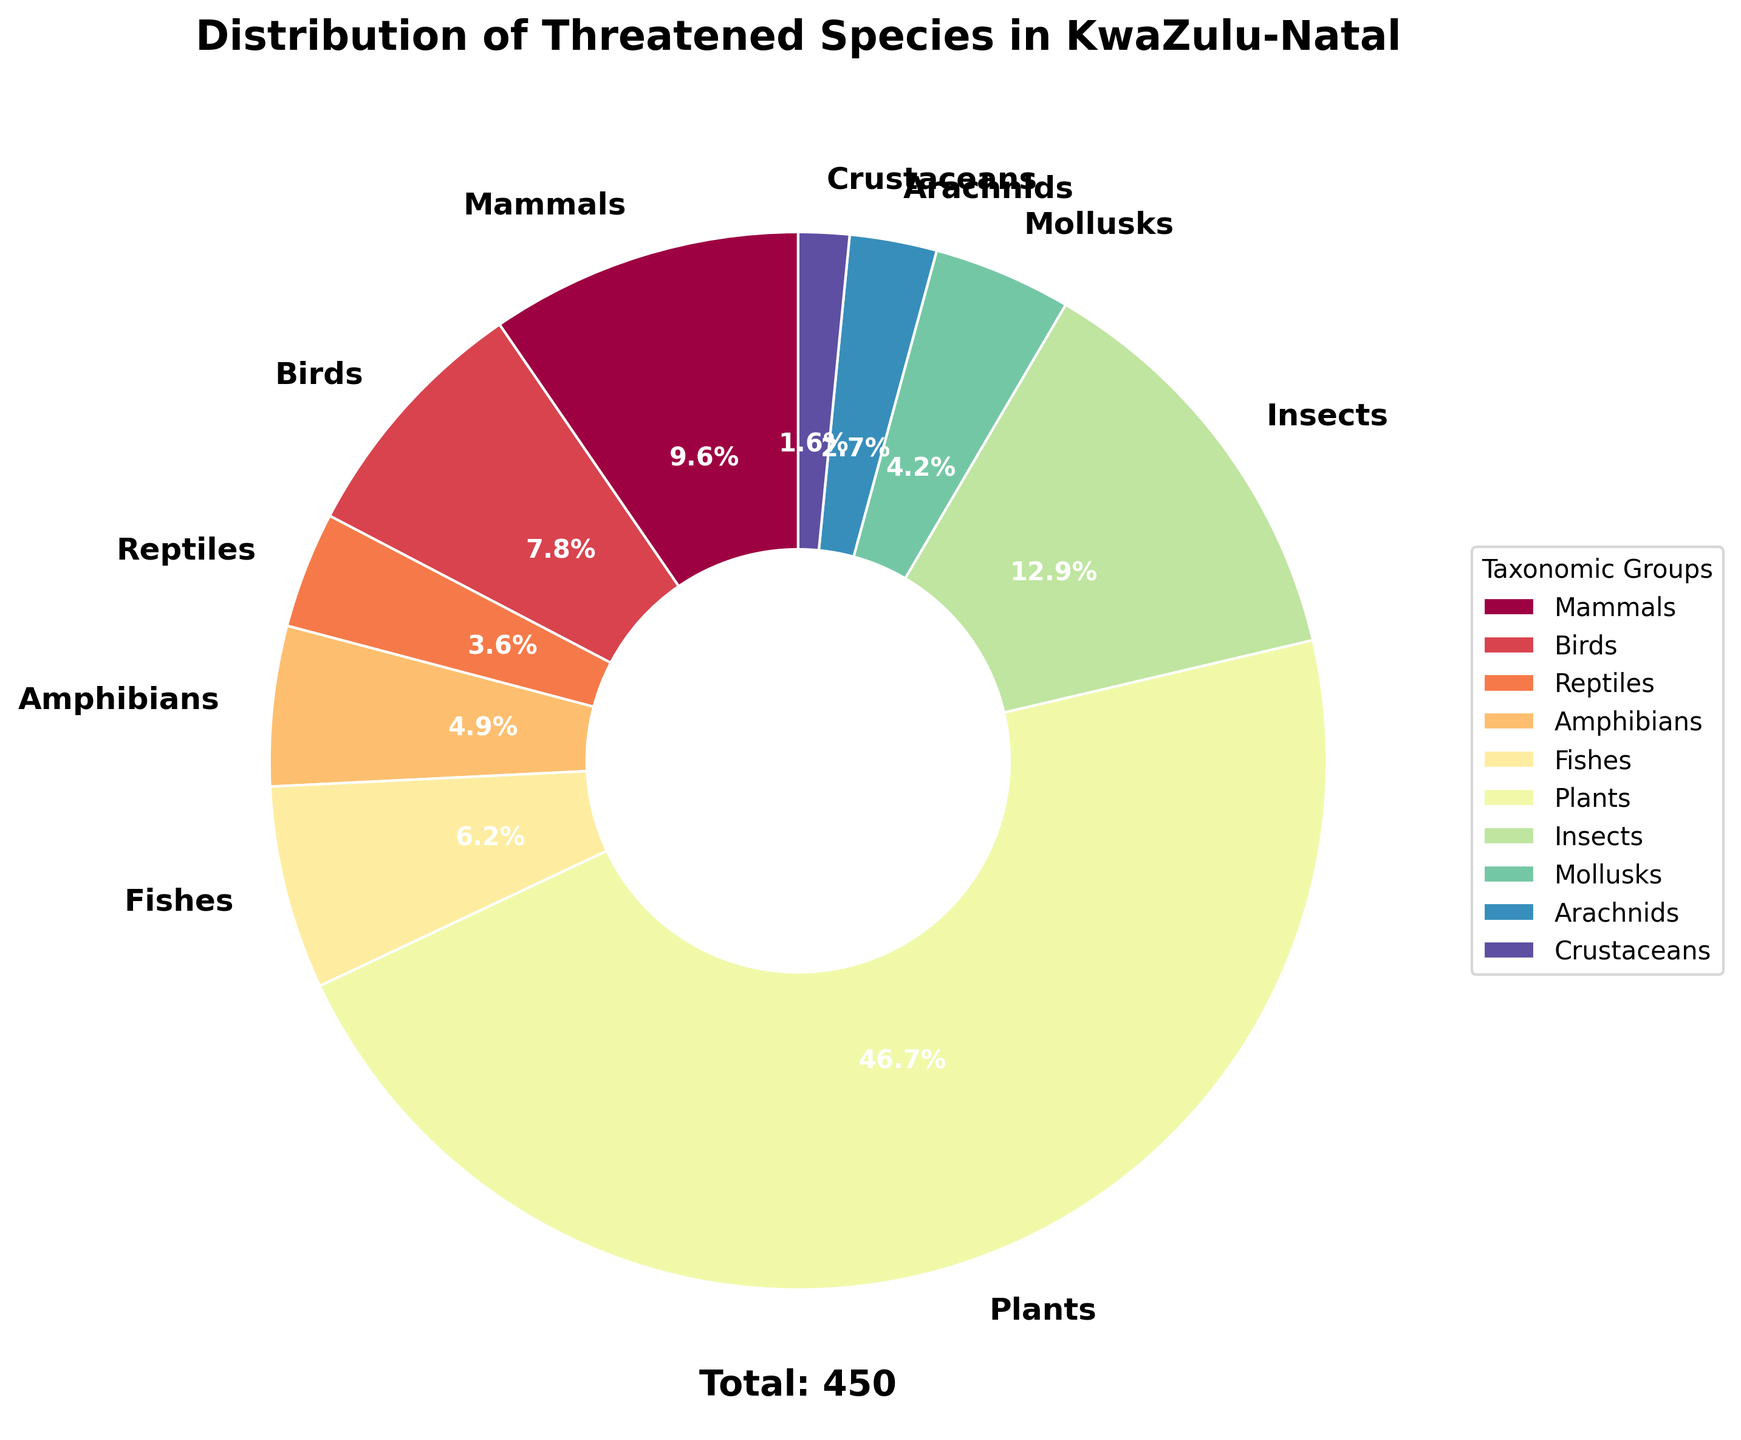What taxonomic group has the largest proportion of threatened species? The pie chart shows the percentages of each taxonomic group. The largest slice represents the taxonomic group with the most threatened species.
Answer: Plants Which taxonomic group has fewer threatened species: Reptiles or Fishes? The pie chart slices corresponding to Reptiles and Fishes show their respective percentages. Comparing the percentages, Fishes has more threatened species than Reptiles.
Answer: Reptiles What is the total number of threatened species accounted for in the pie chart? The total number is given in the text at the bottom of the pie chart. The text states "Total: 450", summing up all threatened species.
Answer: 450 Which two taxonomic groups combined have the same number of threatened species as Plants? Plants has the largest proportion. Combining the two next largest proportions (Insects and Mammals), 58 + 43 = 101, which is still less than 210. Continue trying other combinations until Ithas the same number or more.
Answer: No two groups combined have the same number of threatened species as Plants What percentage of threatened species are Amphibians? The pie chart slices show the percentage for Amphibians. The slice labeled "Amphibians" shows 22 threatened species out of 450.
Answer: 4.9% How many more threatened species are there in Mollusks compared to Arachnids? Mollusks have 19 threatened species while Arachnids have 12, so the difference is 19 - 12.
Answer: 7 Is the number of threatened Insects closer to the number of threatened Plants or Mammals? Comparing the number of threatened Insects (58), Plants (210), and Mammals (43), the Insects are closer to Mammals (43) than Plants (210).
Answer: Mammals What fraction of the threatened species are Crustaceans? Crustaceans have 7 threatened species out of a total of 450. The fraction is thus 7/450.
Answer: 7/450 Which taxonomic group adds up to about 50% of all threatened species along with Fishes? Fishes have 28 threatened species. To find a group that, together with Fishes, makes up about 50%, you look for a group close to 197 (since 0.5 * 450 = 225 - 28).
Answer: None, no single group combines with Fishes to make 50% If the number of threatened Birds doubled, would they have more threatened species than Plants? Currently, Birds have 35 threatened species. Doubling that would result in 70, which is still less than Plants' 210 threatened species.
Answer: No 